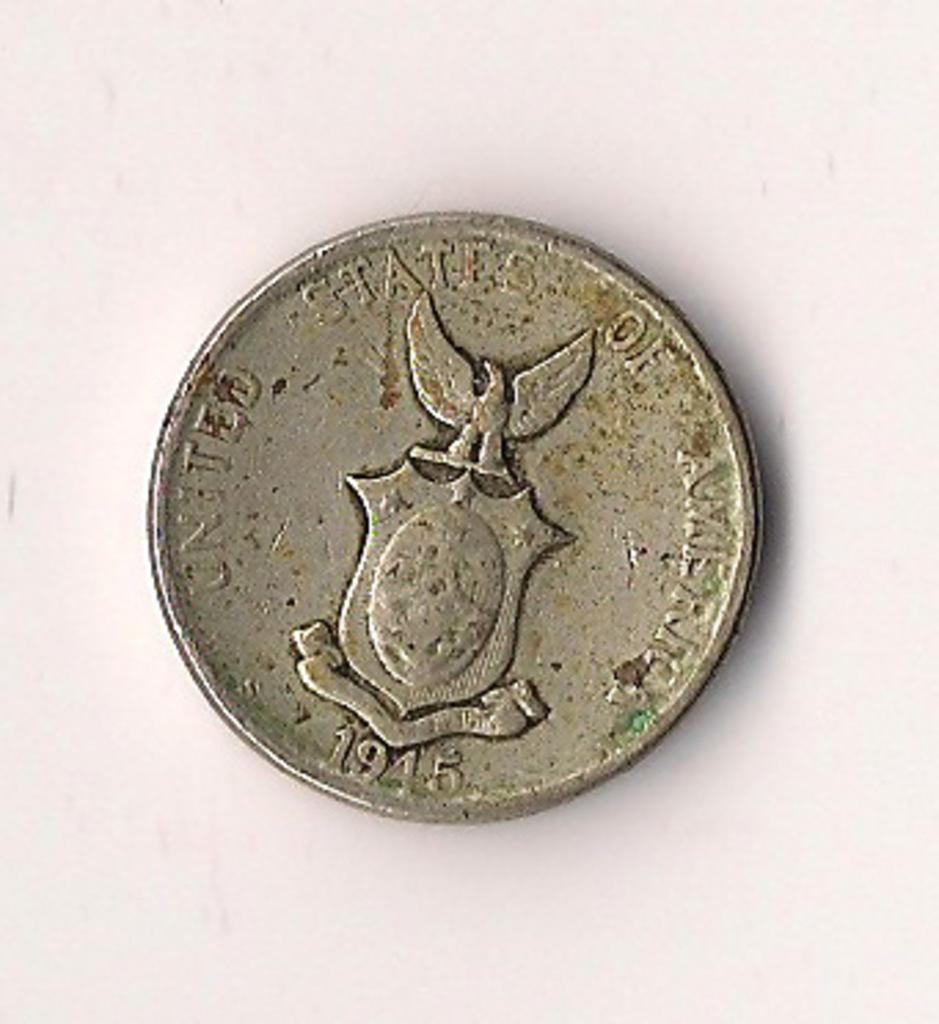What year is displayed on the coin?
Keep it short and to the point. 1945. 